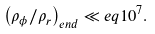<formula> <loc_0><loc_0><loc_500><loc_500>\left ( \rho _ { \phi } / \rho _ { r } \right ) _ { e n d } \ll e q 1 0 ^ { 7 } .</formula> 